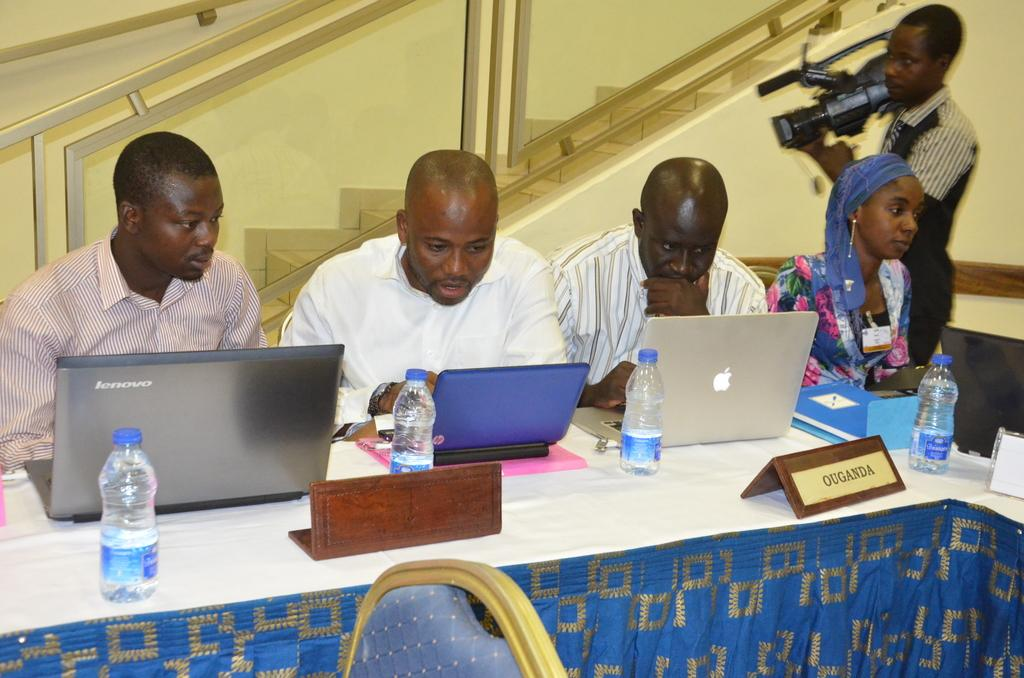<image>
Describe the image concisely. men sitting behind laptops with one of them sitting behind a name that says 'ouganda' 